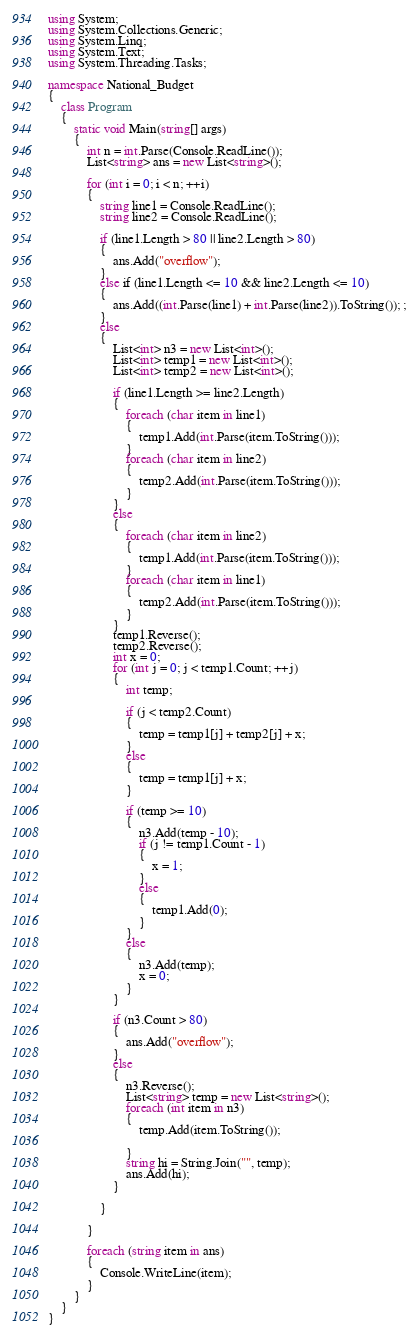Convert code to text. <code><loc_0><loc_0><loc_500><loc_500><_C#_>using System;
using System.Collections.Generic;
using System.Linq;
using System.Text;
using System.Threading.Tasks;

namespace National_Budget
{
    class Program
    {
        static void Main(string[] args)
        {
            int n = int.Parse(Console.ReadLine());
            List<string> ans = new List<string>();

            for (int i = 0; i < n; ++i)
            {
                string line1 = Console.ReadLine();
                string line2 = Console.ReadLine();

                if (line1.Length > 80 || line2.Length > 80)
                {
                    ans.Add("overflow");
                }
                else if (line1.Length <= 10 && line2.Length <= 10)
                {
                    ans.Add((int.Parse(line1) + int.Parse(line2)).ToString()); ;
                }
                else
                {
                    List<int> n3 = new List<int>();
                    List<int> temp1 = new List<int>();
                    List<int> temp2 = new List<int>();

                    if (line1.Length >= line2.Length)
                    {
                        foreach (char item in line1)
                        {
                            temp1.Add(int.Parse(item.ToString()));
                        }
                        foreach (char item in line2)
                        {
                            temp2.Add(int.Parse(item.ToString()));
                        }
                    }
                    else
                    {
                        foreach (char item in line2)
                        {
                            temp1.Add(int.Parse(item.ToString()));
                        }
                        foreach (char item in line1)
                        {
                            temp2.Add(int.Parse(item.ToString()));
                        }
                    }
                    temp1.Reverse();
                    temp2.Reverse();
                    int x = 0;
                    for (int j = 0; j < temp1.Count; ++j)
                    {
                        int temp;

                        if (j < temp2.Count)
                        {
                            temp = temp1[j] + temp2[j] + x;
                        }
                        else
                        {
                            temp = temp1[j] + x;
                        }

                        if (temp >= 10)
                        {
                            n3.Add(temp - 10);
                            if (j != temp1.Count - 1)
                            {
                                x = 1;
                            }
                            else
                            {
                                temp1.Add(0);
                            }
                        }
                        else
                        {
                            n3.Add(temp);
                            x = 0;
                        }
                    }

                    if (n3.Count > 80)
                    {
                        ans.Add("overflow");
                    }
                    else
                    {
                        n3.Reverse();
                        List<string> temp = new List<string>();
                        foreach (int item in n3)
                        {
                            temp.Add(item.ToString());

                        }
                        string hi = String.Join("", temp);
                        ans.Add(hi);
                    }

                }

            }

            foreach (string item in ans)
            {
                Console.WriteLine(item);
            }
        }
    }
}

</code> 